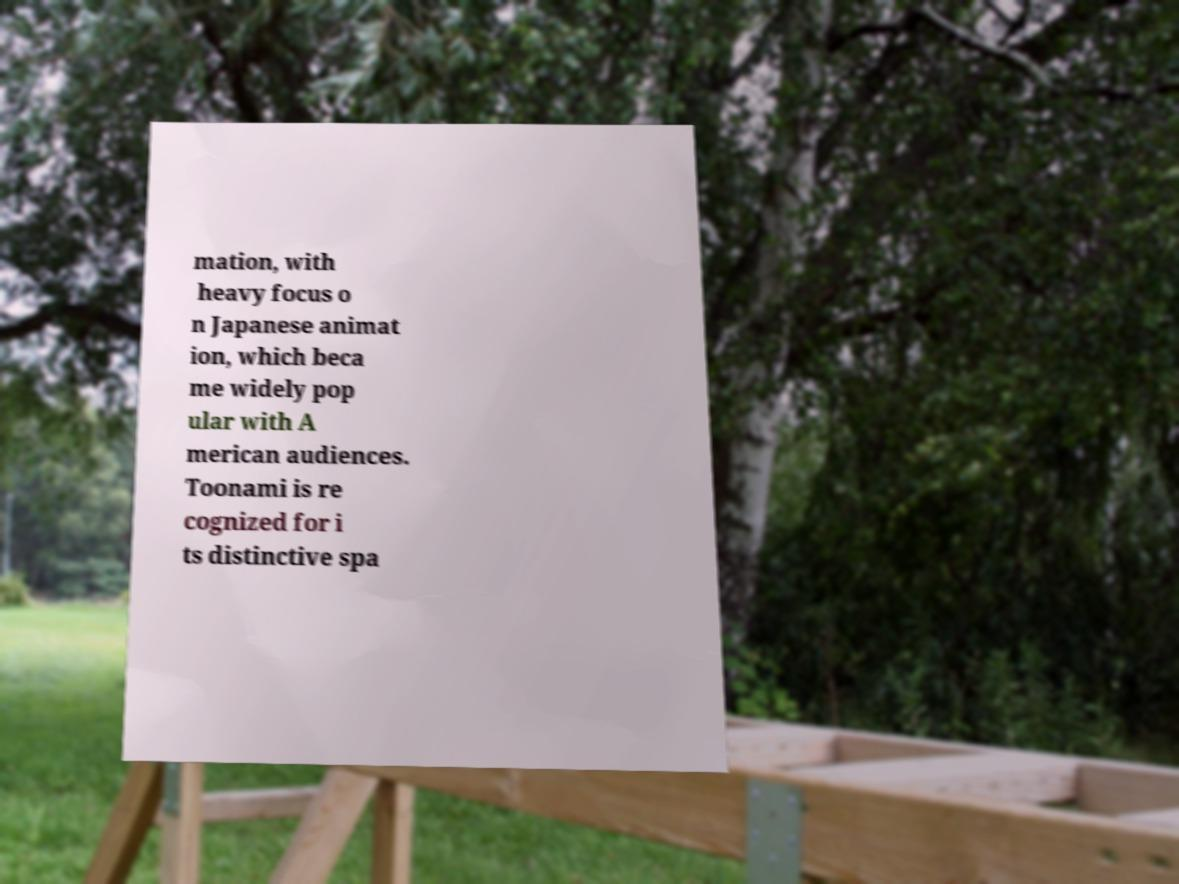I need the written content from this picture converted into text. Can you do that? mation, with heavy focus o n Japanese animat ion, which beca me widely pop ular with A merican audiences. Toonami is re cognized for i ts distinctive spa 